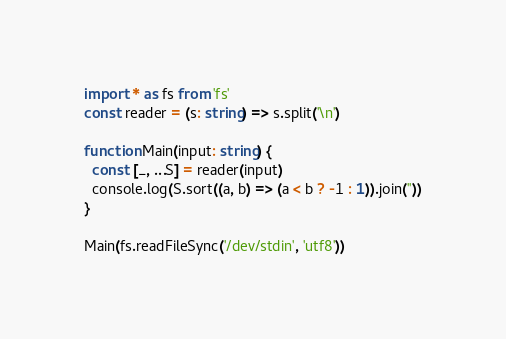Convert code to text. <code><loc_0><loc_0><loc_500><loc_500><_TypeScript_>import * as fs from 'fs'
const reader = (s: string) => s.split('\n')

function Main(input: string) {
  const [_, ...S] = reader(input)
  console.log(S.sort((a, b) => (a < b ? -1 : 1)).join(''))
}

Main(fs.readFileSync('/dev/stdin', 'utf8'))

</code> 